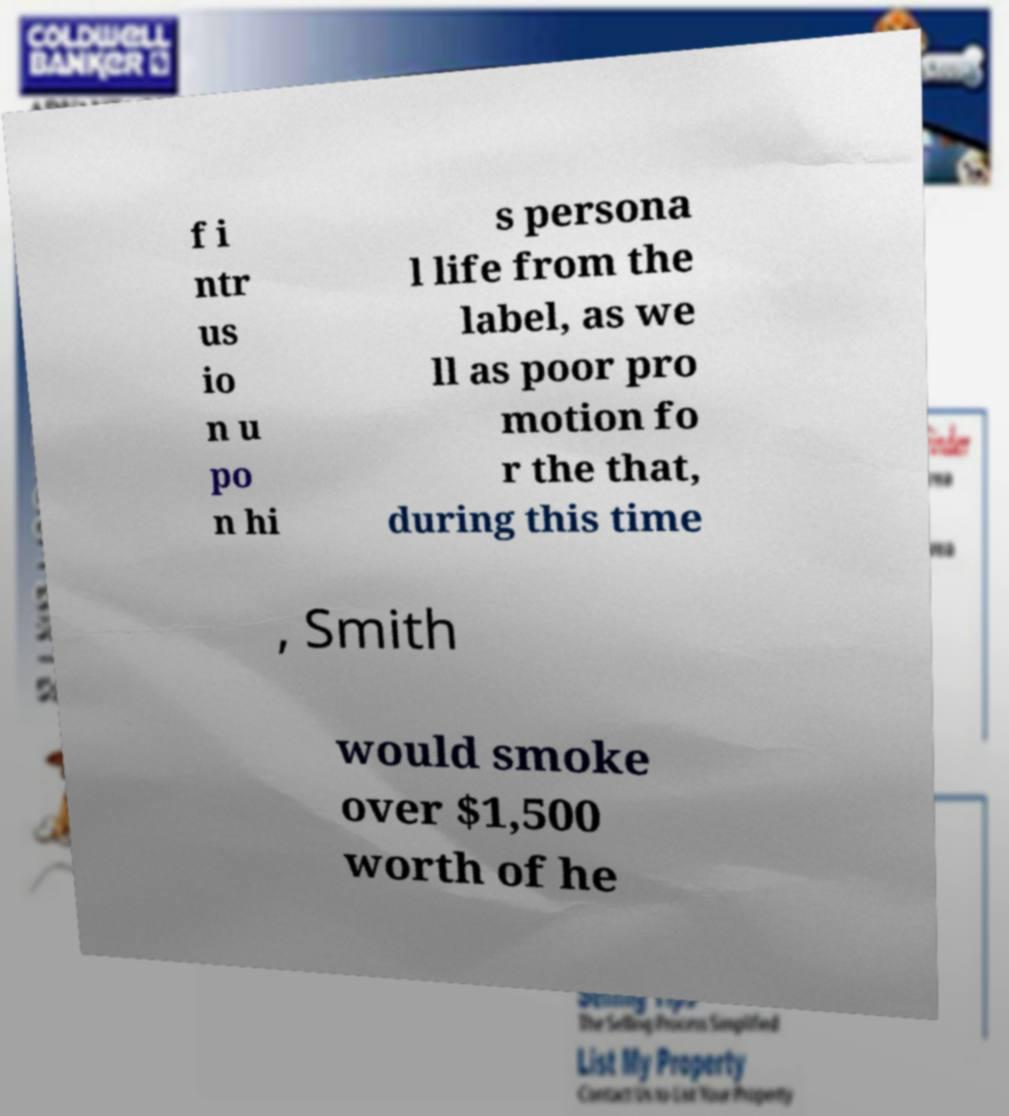Can you accurately transcribe the text from the provided image for me? f i ntr us io n u po n hi s persona l life from the label, as we ll as poor pro motion fo r the that, during this time , Smith would smoke over $1,500 worth of he 